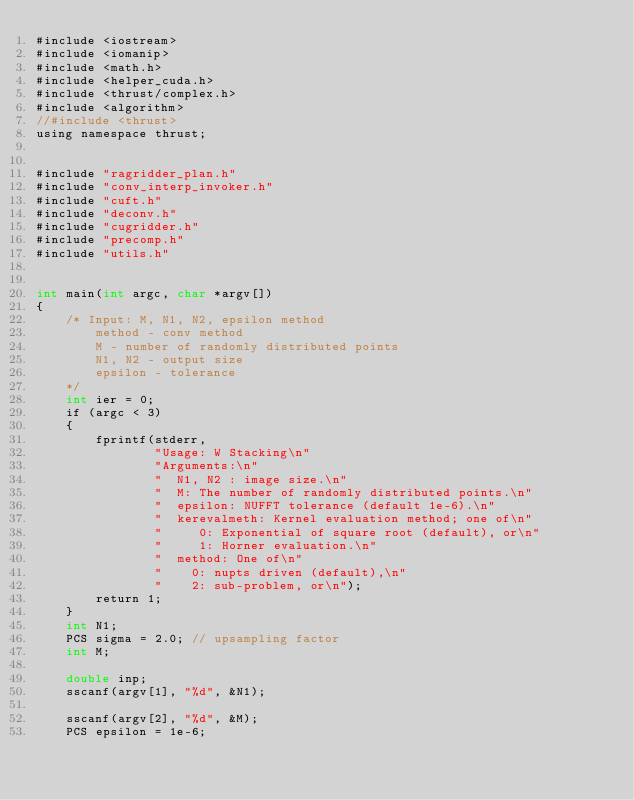<code> <loc_0><loc_0><loc_500><loc_500><_Cuda_>#include <iostream>
#include <iomanip>
#include <math.h>
#include <helper_cuda.h>
#include <thrust/complex.h>
#include <algorithm>
//#include <thrust>
using namespace thrust;


#include "ragridder_plan.h"
#include "conv_interp_invoker.h"
#include "cuft.h"
#include "deconv.h"
#include "cugridder.h"
#include "precomp.h"
#include "utils.h"


int main(int argc, char *argv[])
{
	/* Input: M, N1, N2, epsilon method
		method - conv method
		M - number of randomly distributed points
		N1, N2 - output size
		epsilon - tolerance
	*/
	int ier = 0;
	if (argc < 3)
	{
		fprintf(stderr,
				"Usage: W Stacking\n"
				"Arguments:\n"
				"  N1, N2 : image size.\n"
				"  M: The number of randomly distributed points.\n"
				"  epsilon: NUFFT tolerance (default 1e-6).\n"
				"  kerevalmeth: Kernel evaluation method; one of\n"
				"     0: Exponential of square root (default), or\n"
				"     1: Horner evaluation.\n"
				"  method: One of\n"
				"    0: nupts driven (default),\n"
				"    2: sub-problem, or\n");
		return 1;
	}
	int N1;
	PCS sigma = 2.0; // upsampling factor
	int M;

	double inp;
	sscanf(argv[1], "%d", &N1);
	
	sscanf(argv[2], "%d", &M);
	PCS epsilon = 1e-6;</code> 